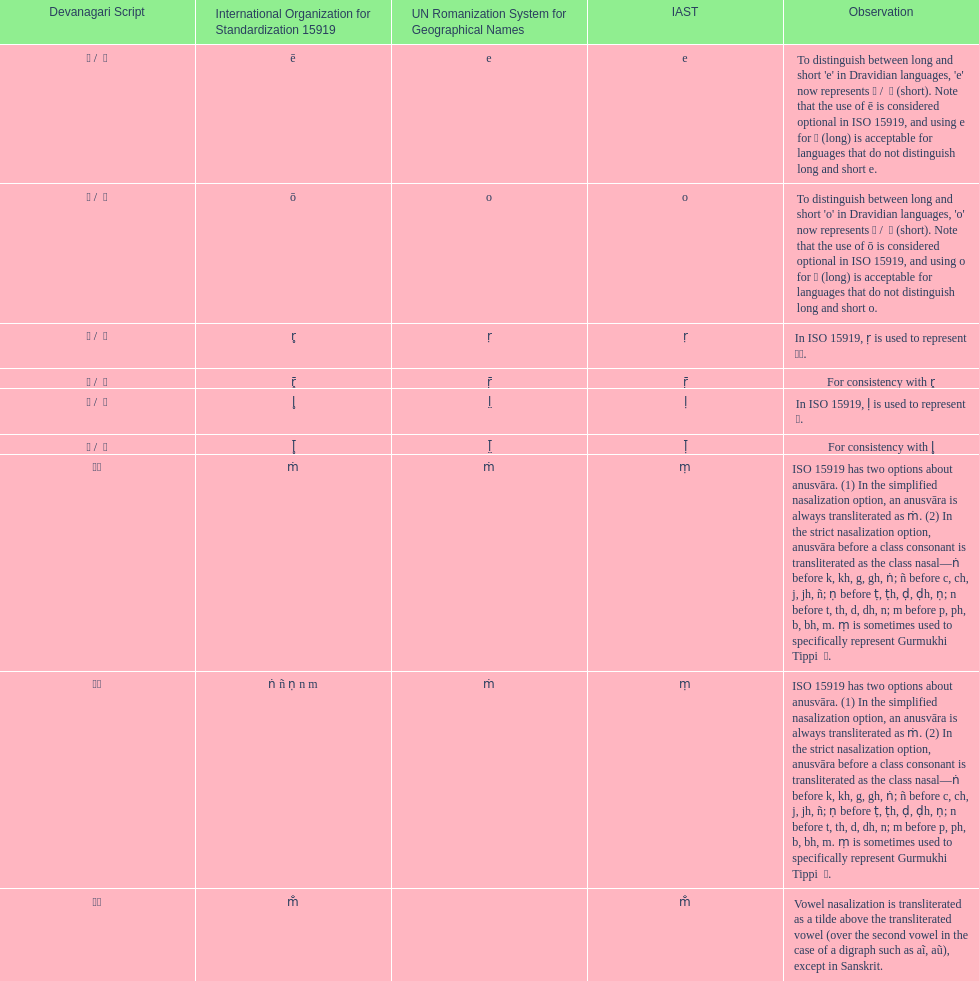What iast is listed before the o? E. 